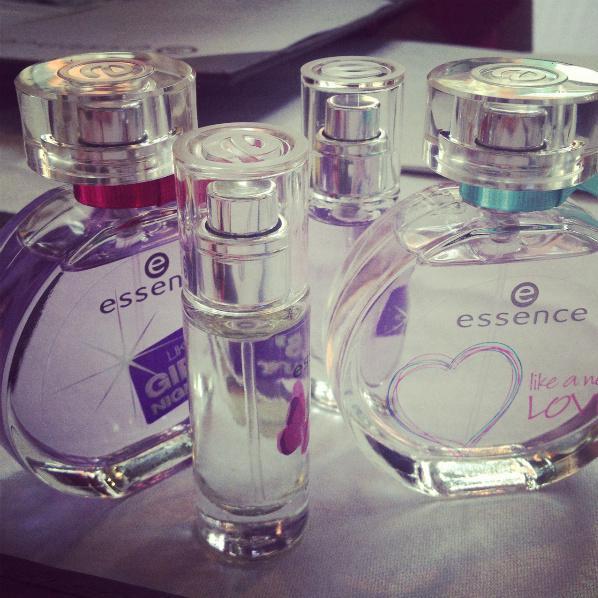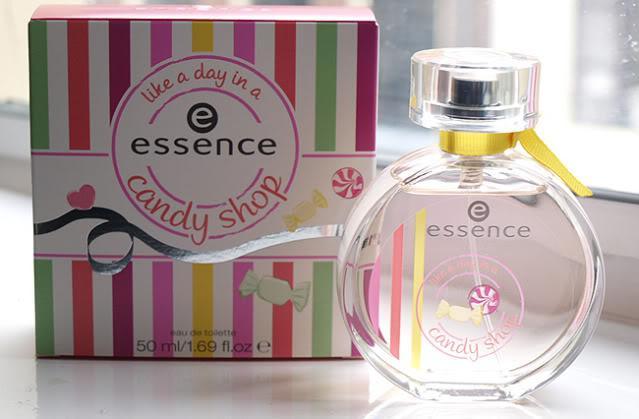The first image is the image on the left, the second image is the image on the right. For the images displayed, is the sentence "The right image shows exactly one perfume in a circular bottle." factually correct? Answer yes or no. Yes. 